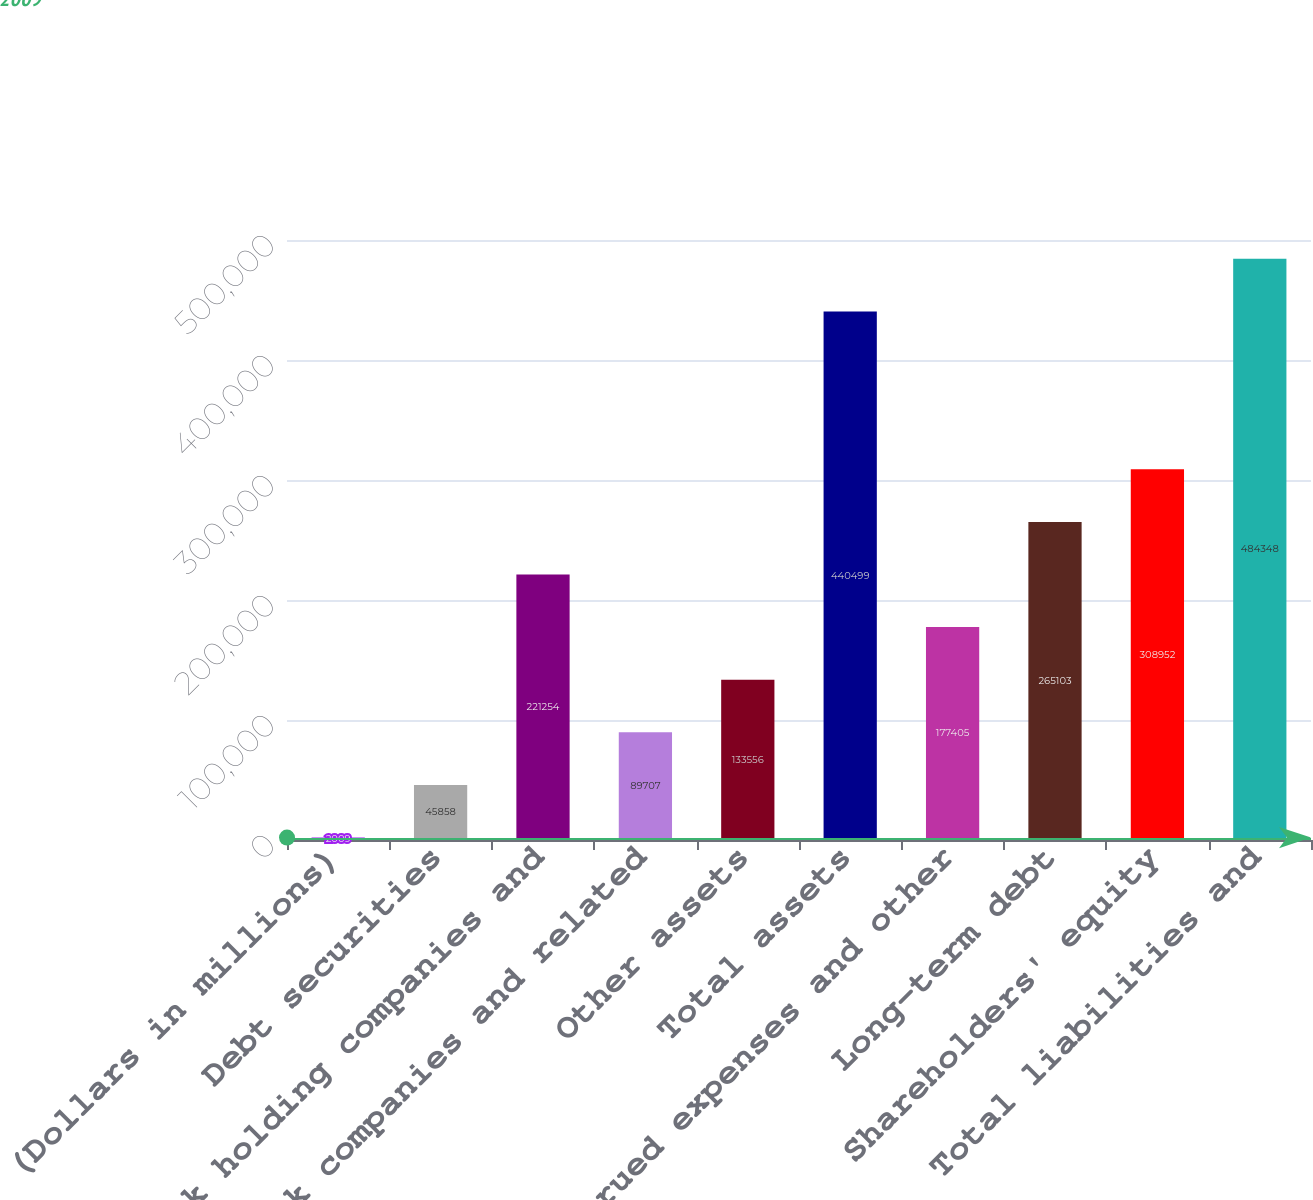Convert chart. <chart><loc_0><loc_0><loc_500><loc_500><bar_chart><fcel>(Dollars in millions)<fcel>Debt securities<fcel>Bank holding companies and<fcel>Nonbank companies and related<fcel>Other assets<fcel>Total assets<fcel>Accrued expenses and other<fcel>Long-term debt<fcel>Shareholders' equity<fcel>Total liabilities and<nl><fcel>2009<fcel>45858<fcel>221254<fcel>89707<fcel>133556<fcel>440499<fcel>177405<fcel>265103<fcel>308952<fcel>484348<nl></chart> 